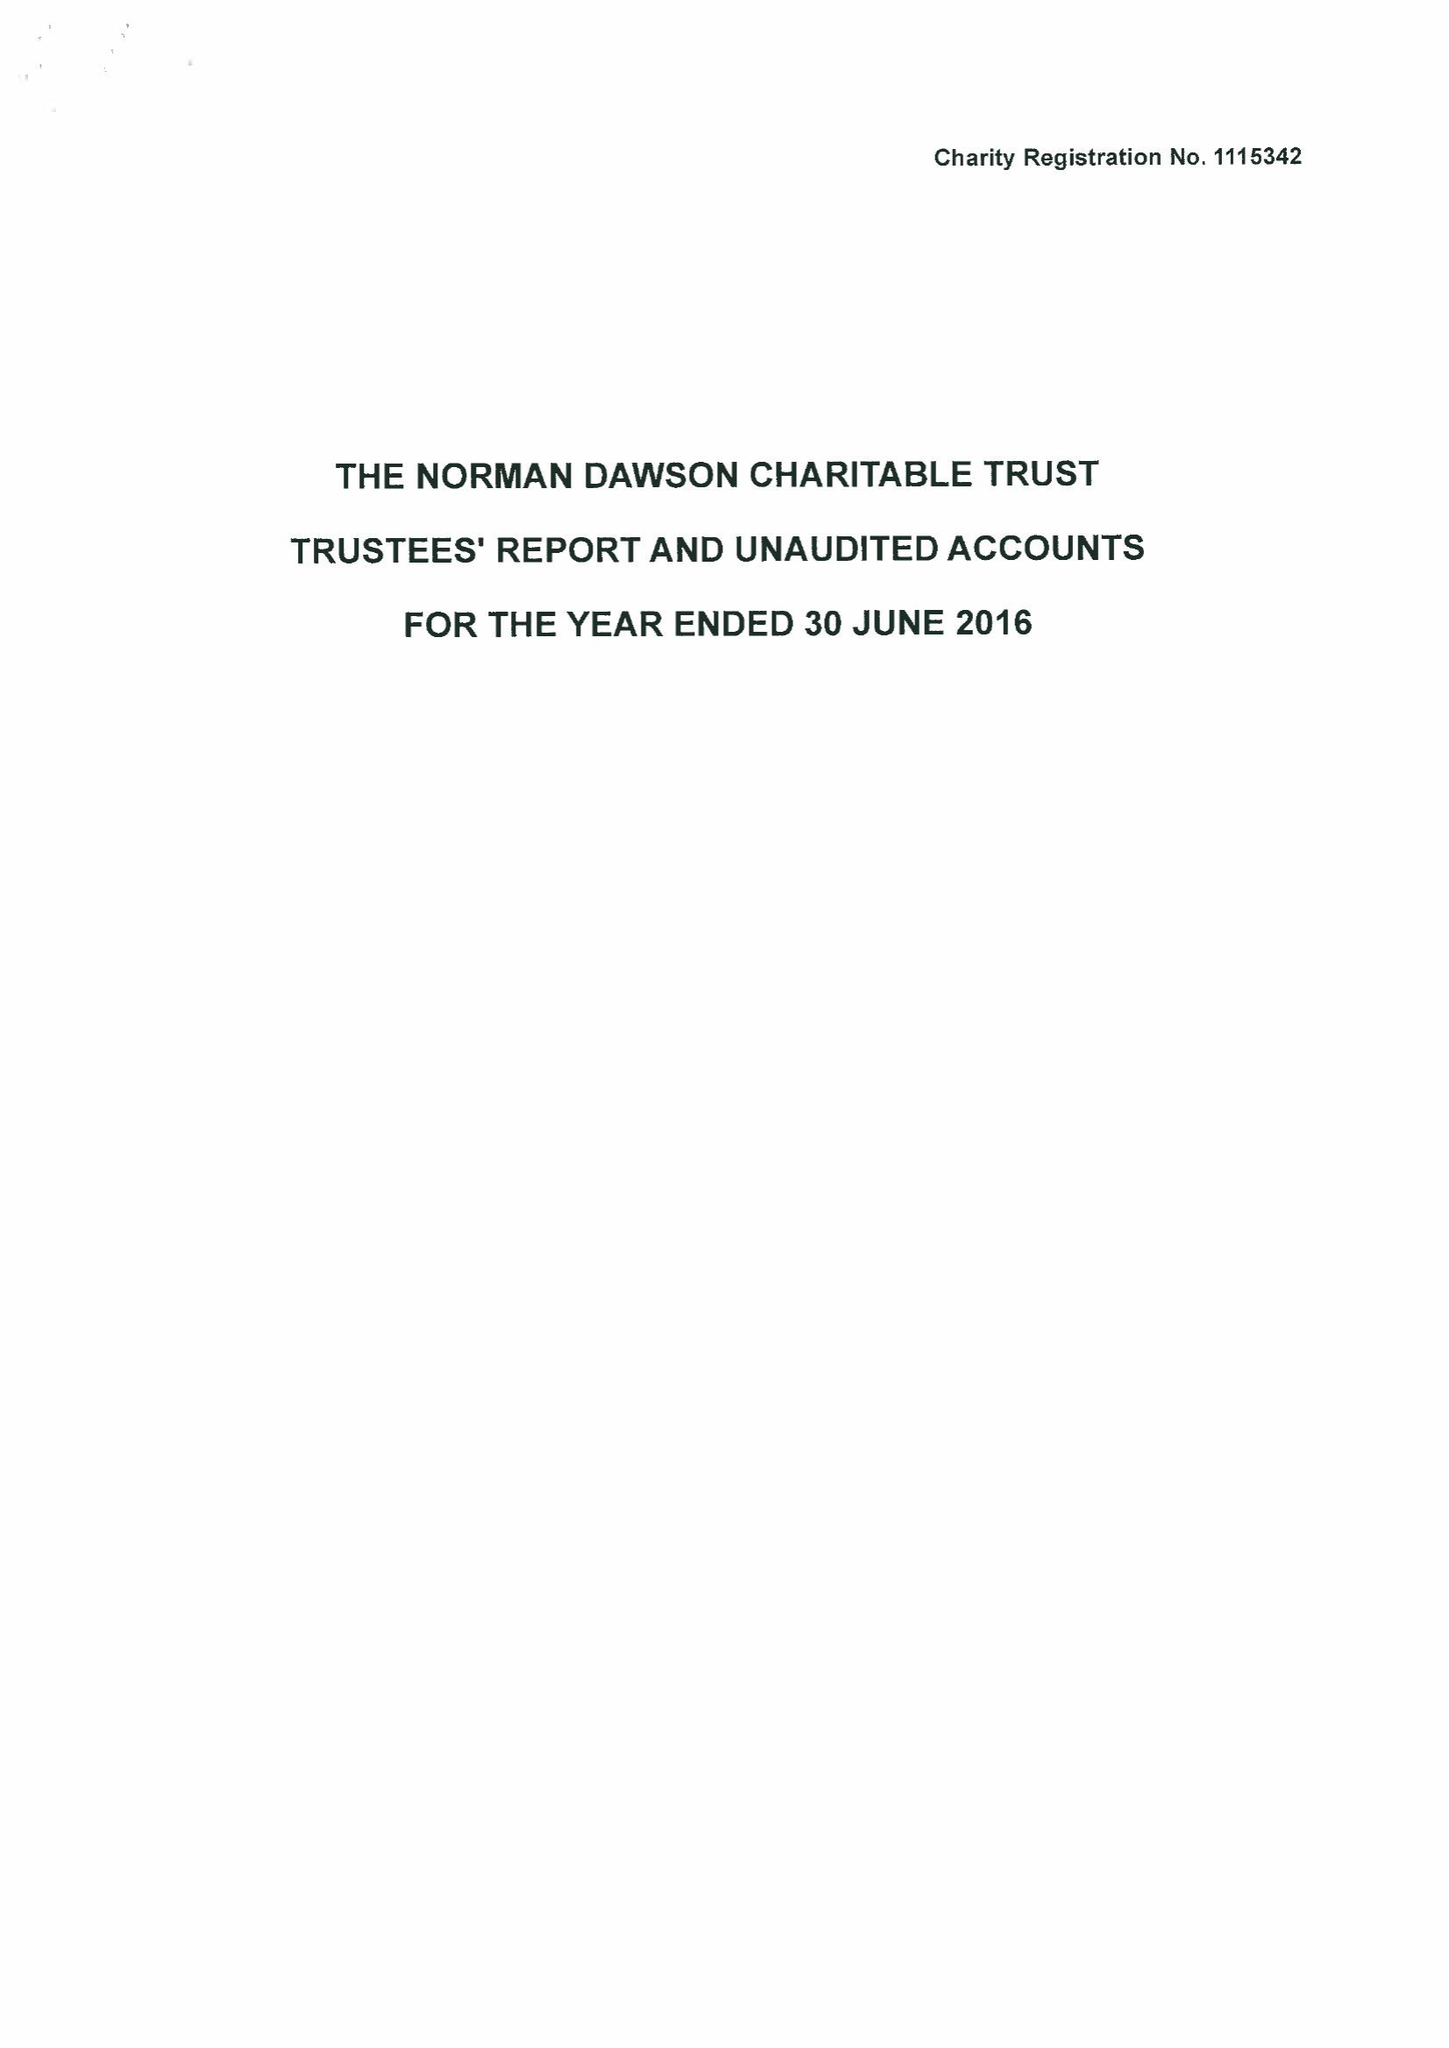What is the value for the spending_annually_in_british_pounds?
Answer the question using a single word or phrase. 109271.00 